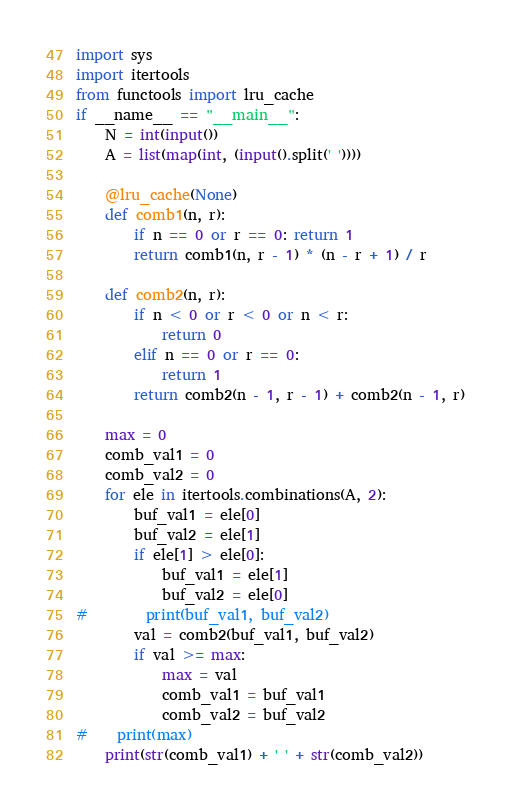<code> <loc_0><loc_0><loc_500><loc_500><_Python_>import sys
import itertools
from functools import lru_cache
if __name__ == "__main__":
    N = int(input())
    A = list(map(int, (input().split(' '))))

    @lru_cache(None)
    def comb1(n, r):
        if n == 0 or r == 0: return 1
        return comb1(n, r - 1) * (n - r + 1) / r

    def comb2(n, r):
        if n < 0 or r < 0 or n < r:
            return 0
        elif n == 0 or r == 0:
            return 1
        return comb2(n - 1, r - 1) + comb2(n - 1, r)

    max = 0
    comb_val1 = 0
    comb_val2 = 0
    for ele in itertools.combinations(A, 2):
        buf_val1 = ele[0]
        buf_val2 = ele[1]
        if ele[1] > ele[0]:
            buf_val1 = ele[1]
            buf_val2 = ele[0]
#        print(buf_val1, buf_val2)
        val = comb2(buf_val1, buf_val2)
        if val >= max:
            max = val
            comb_val1 = buf_val1
            comb_val2 = buf_val2
#    print(max)
    print(str(comb_val1) + ' ' + str(comb_val2))</code> 